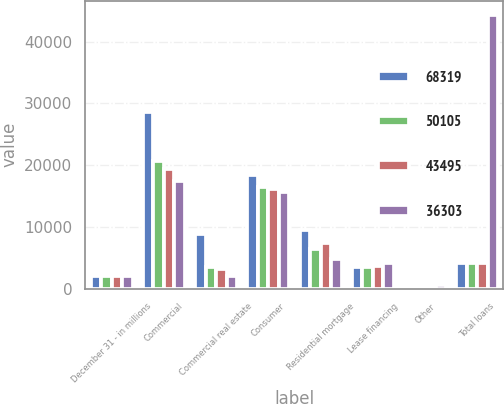Convert chart to OTSL. <chart><loc_0><loc_0><loc_500><loc_500><stacked_bar_chart><ecel><fcel>December 31 - in millions<fcel>Commercial<fcel>Commercial real estate<fcel>Consumer<fcel>Residential mortgage<fcel>Lease financing<fcel>Other<fcel>Total loans<nl><fcel>68319<fcel>2007<fcel>28607<fcel>8906<fcel>18326<fcel>9557<fcel>3500<fcel>413<fcel>4096<nl><fcel>50105<fcel>2006<fcel>20584<fcel>3532<fcel>16515<fcel>6337<fcel>3556<fcel>376<fcel>4096<nl><fcel>43495<fcel>2005<fcel>19325<fcel>3162<fcel>16173<fcel>7307<fcel>3628<fcel>341<fcel>4096<nl><fcel>36303<fcel>2004<fcel>17438<fcel>1980<fcel>15606<fcel>4772<fcel>4096<fcel>505<fcel>44397<nl></chart> 